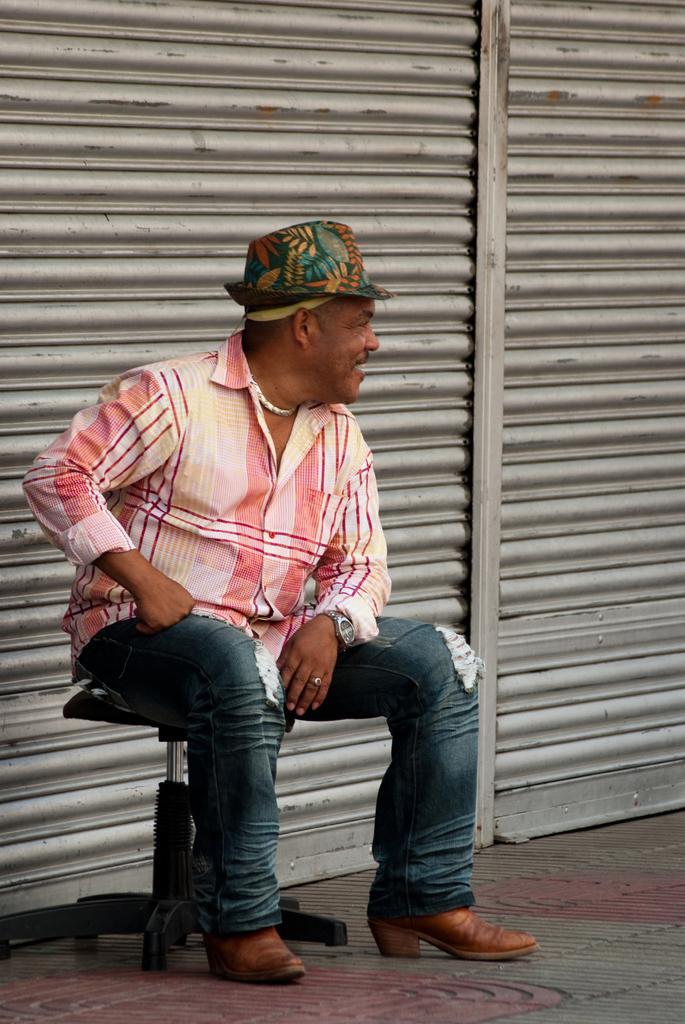Can you describe this image briefly? In this image in the foreground there is one man who is sitting on a chair, in the background there are shutters. At the bottom there is a walkway. 